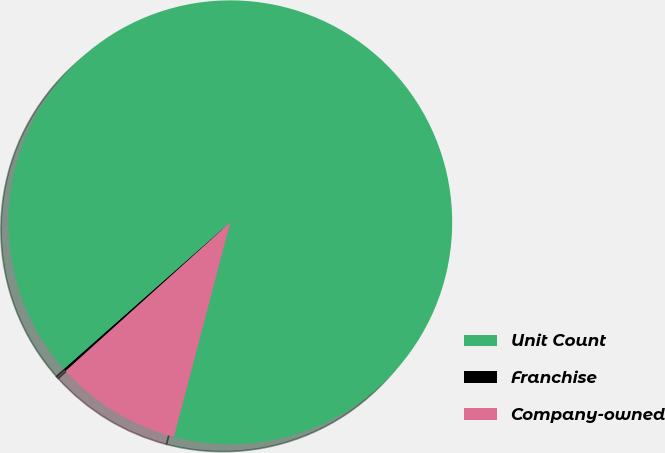<chart> <loc_0><loc_0><loc_500><loc_500><pie_chart><fcel>Unit Count<fcel>Franchise<fcel>Company-owned<nl><fcel>90.6%<fcel>0.18%<fcel>9.22%<nl></chart> 